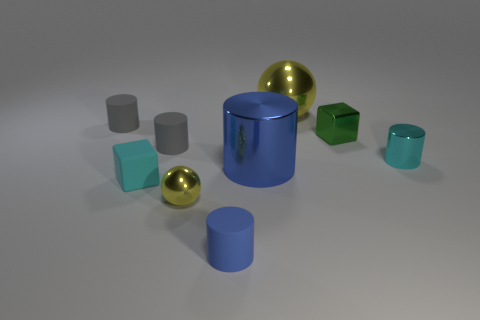Subtract all purple spheres. How many blue cylinders are left? 2 Subtract all tiny matte cylinders. How many cylinders are left? 2 Subtract all gray cylinders. How many cylinders are left? 3 Subtract all balls. How many objects are left? 7 Subtract all brown cylinders. Subtract all green balls. How many cylinders are left? 5 Add 5 tiny cyan cylinders. How many tiny cyan cylinders are left? 6 Add 4 shiny balls. How many shiny balls exist? 6 Subtract 1 cyan cubes. How many objects are left? 8 Subtract all big shiny spheres. Subtract all small blocks. How many objects are left? 6 